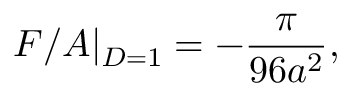Convert formula to latex. <formula><loc_0><loc_0><loc_500><loc_500>F / A | _ { D = 1 } = - { \frac { \pi } { 9 6 a ^ { 2 } } } ,</formula> 